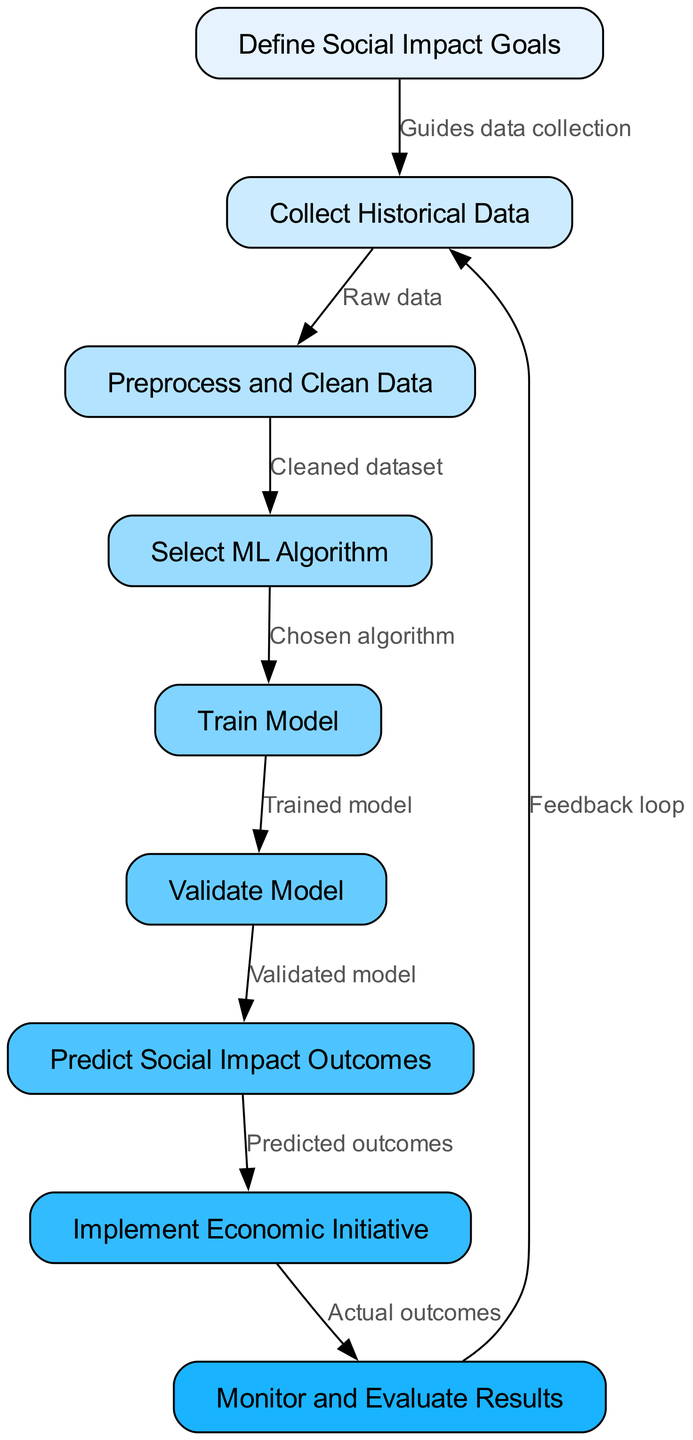What is the first step in the flowchart? The first step in the flowchart is represented by the node labeled "Define Social Impact Goals." This node is located at the top of the diagram and indicates that establishing clear social impact goals is the starting point of the process.
Answer: Define Social Impact Goals How many nodes are in the diagram? By counting each node represented in the diagram, we find there are nine distinct nodes, each corresponding to a specific step in the machine learning process for predicting social impact outcomes.
Answer: 9 What guides the data collection? The data collection is guided by the first node, which is "Define Social Impact Goals." This means that a clear definition of goals informs and directs what historical data needs to be collected for analysis.
Answer: Guides data collection What is the output of the "Train Model" step? The output of the "Train Model" step is the "Trained Model," which indicates that after this process, the model is prepared for further evaluation and predictions. This can be seen flowing from the "Train Model" node to the "Validate Model" node.
Answer: Trained Model Which node does the "Monitor and Evaluate Results" step lead to after implementing the initiative? After implementing the initiative, the "Monitor and Evaluate Results" step leads back to the "Collect Historical Data" node. This indicates a feedback loop for continual improvement based on the results observed.
Answer: Collect Historical Data What is the purpose of the edge labeled "Validated model"? The edge labeled "Validated model" connects the "Validate Model" node to the "Predict Social Impact Outcomes" node. Its purpose is to signify that validation ensures the model is ready to make predictions about social impact outcomes, thereby playing a crucial role in the overall process.
Answer: Validated model Which two nodes are connected by a feedback loop? The nodes connected by a feedback loop are "Monitor and Evaluate Results" and "Collect Historical Data." This indicates that insights gained from monitoring and evaluation will inform future data collection efforts.
Answer: Monitor and Evaluate Results and Collect Historical Data What happens after predicting social impact outcomes? After predicting social impact outcomes, the process moves to the "Implement Economic Initiative" step, indicating that the predictions lead directly to the real-world application of economic strategies.
Answer: Implement Economic Initiative How does the "Preprocess and Clean Data" step influence the next action? The "Preprocess and Clean Data" step influences the next action by providing a "Cleaned dataset" that feeds into the next node, "Select ML Algorithm." A clean dataset is essential for effective machine learning as it enhances the quality and reliability of the analysis.
Answer: Cleaned dataset 